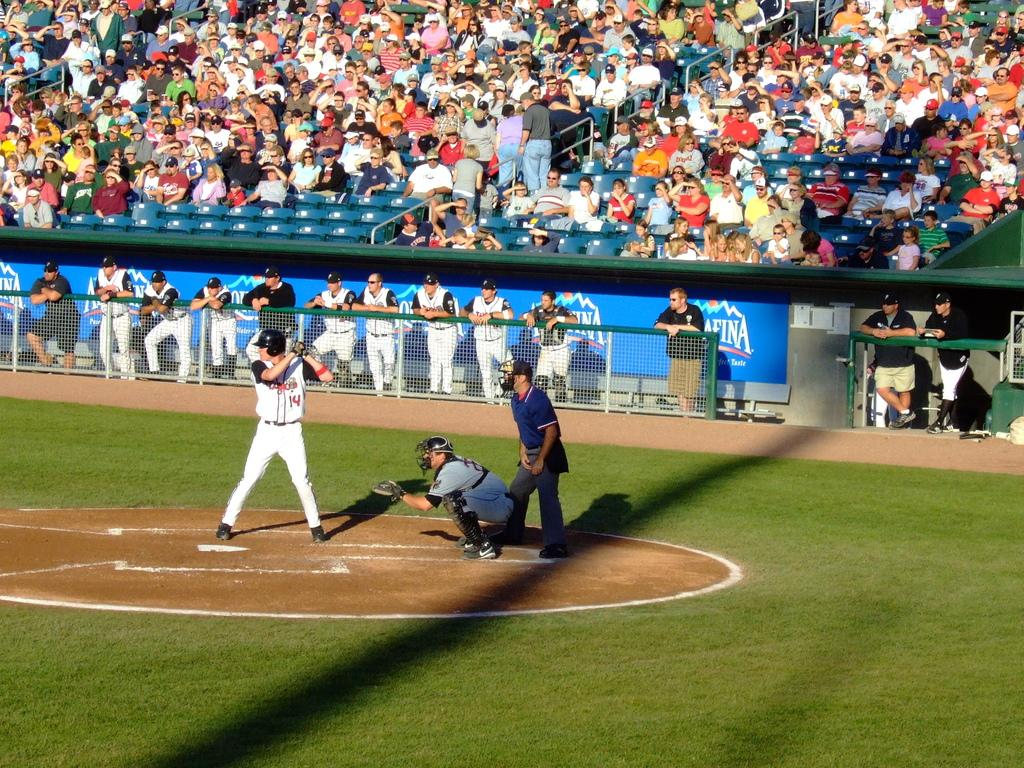<image>
Give a short and clear explanation of the subsequent image. Baseball player 14 getting ready to hit a ball thrown at him. 